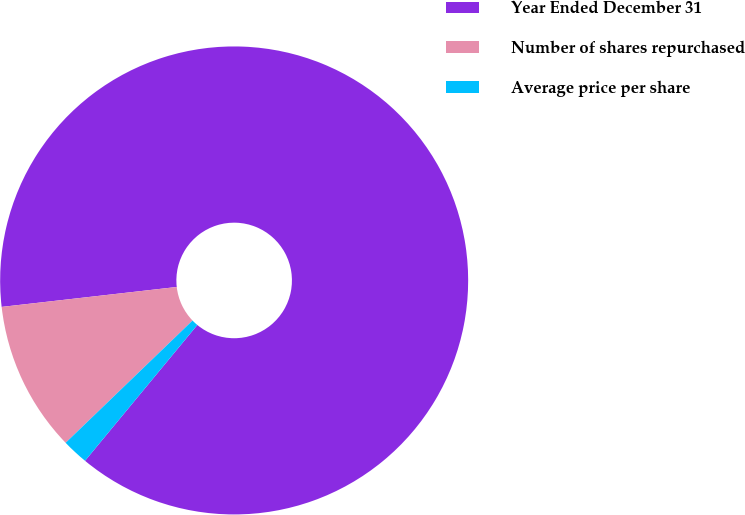<chart> <loc_0><loc_0><loc_500><loc_500><pie_chart><fcel>Year Ended December 31<fcel>Number of shares repurchased<fcel>Average price per share<nl><fcel>87.8%<fcel>10.4%<fcel>1.8%<nl></chart> 